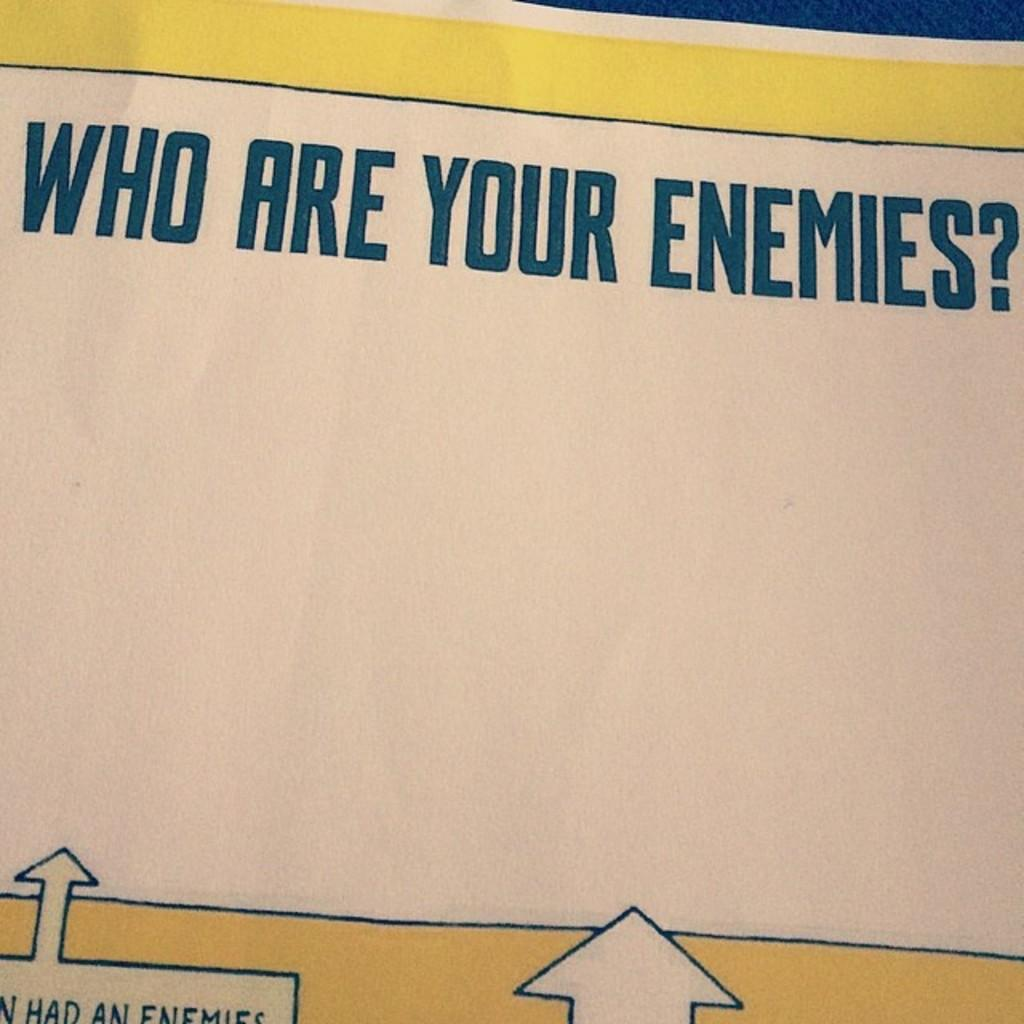<image>
Write a terse but informative summary of the picture. A piece of paper that says "Who Are Your Enemies?" 